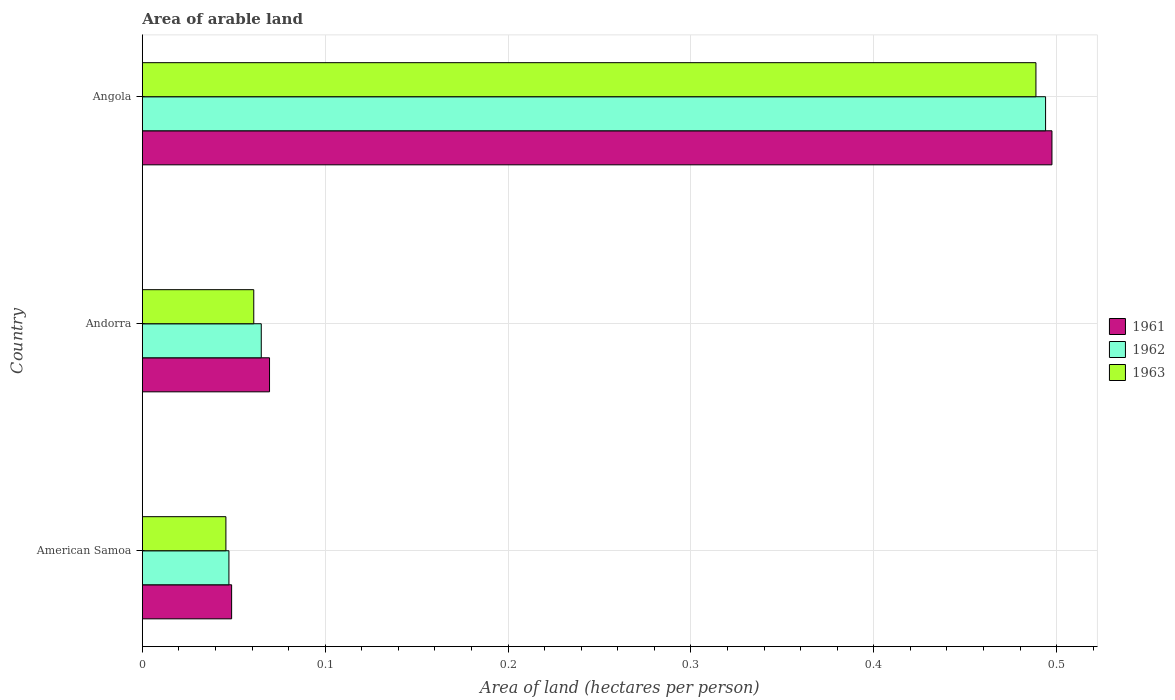Are the number of bars per tick equal to the number of legend labels?
Your answer should be compact. Yes. Are the number of bars on each tick of the Y-axis equal?
Your answer should be compact. Yes. How many bars are there on the 1st tick from the top?
Offer a terse response. 3. What is the label of the 1st group of bars from the top?
Make the answer very short. Angola. What is the total arable land in 1963 in Andorra?
Keep it short and to the point. 0.06. Across all countries, what is the maximum total arable land in 1962?
Make the answer very short. 0.49. Across all countries, what is the minimum total arable land in 1962?
Make the answer very short. 0.05. In which country was the total arable land in 1963 maximum?
Your answer should be compact. Angola. In which country was the total arable land in 1962 minimum?
Give a very brief answer. American Samoa. What is the total total arable land in 1962 in the graph?
Your answer should be compact. 0.61. What is the difference between the total arable land in 1963 in American Samoa and that in Angola?
Keep it short and to the point. -0.44. What is the difference between the total arable land in 1962 in Andorra and the total arable land in 1961 in Angola?
Provide a succinct answer. -0.43. What is the average total arable land in 1963 per country?
Your answer should be compact. 0.2. What is the difference between the total arable land in 1961 and total arable land in 1962 in Angola?
Ensure brevity in your answer.  0. What is the ratio of the total arable land in 1961 in American Samoa to that in Angola?
Offer a terse response. 0.1. Is the total arable land in 1963 in American Samoa less than that in Angola?
Provide a succinct answer. Yes. Is the difference between the total arable land in 1961 in American Samoa and Angola greater than the difference between the total arable land in 1962 in American Samoa and Angola?
Your response must be concise. No. What is the difference between the highest and the second highest total arable land in 1961?
Your response must be concise. 0.43. What is the difference between the highest and the lowest total arable land in 1962?
Your response must be concise. 0.45. In how many countries, is the total arable land in 1961 greater than the average total arable land in 1961 taken over all countries?
Make the answer very short. 1. What does the 3rd bar from the top in Angola represents?
Give a very brief answer. 1961. What does the 2nd bar from the bottom in American Samoa represents?
Make the answer very short. 1962. Are all the bars in the graph horizontal?
Give a very brief answer. Yes. How many countries are there in the graph?
Your answer should be very brief. 3. Are the values on the major ticks of X-axis written in scientific E-notation?
Make the answer very short. No. Does the graph contain any zero values?
Offer a terse response. No. Does the graph contain grids?
Your answer should be compact. Yes. Where does the legend appear in the graph?
Keep it short and to the point. Center right. How many legend labels are there?
Your response must be concise. 3. How are the legend labels stacked?
Offer a terse response. Vertical. What is the title of the graph?
Your response must be concise. Area of arable land. Does "1996" appear as one of the legend labels in the graph?
Keep it short and to the point. No. What is the label or title of the X-axis?
Your answer should be compact. Area of land (hectares per person). What is the Area of land (hectares per person) in 1961 in American Samoa?
Keep it short and to the point. 0.05. What is the Area of land (hectares per person) in 1962 in American Samoa?
Give a very brief answer. 0.05. What is the Area of land (hectares per person) in 1963 in American Samoa?
Provide a succinct answer. 0.05. What is the Area of land (hectares per person) in 1961 in Andorra?
Keep it short and to the point. 0.07. What is the Area of land (hectares per person) of 1962 in Andorra?
Give a very brief answer. 0.07. What is the Area of land (hectares per person) of 1963 in Andorra?
Give a very brief answer. 0.06. What is the Area of land (hectares per person) of 1961 in Angola?
Your answer should be very brief. 0.5. What is the Area of land (hectares per person) in 1962 in Angola?
Your answer should be compact. 0.49. What is the Area of land (hectares per person) in 1963 in Angola?
Ensure brevity in your answer.  0.49. Across all countries, what is the maximum Area of land (hectares per person) in 1961?
Give a very brief answer. 0.5. Across all countries, what is the maximum Area of land (hectares per person) of 1962?
Provide a short and direct response. 0.49. Across all countries, what is the maximum Area of land (hectares per person) of 1963?
Your answer should be compact. 0.49. Across all countries, what is the minimum Area of land (hectares per person) of 1961?
Offer a very short reply. 0.05. Across all countries, what is the minimum Area of land (hectares per person) of 1962?
Offer a very short reply. 0.05. Across all countries, what is the minimum Area of land (hectares per person) in 1963?
Give a very brief answer. 0.05. What is the total Area of land (hectares per person) of 1961 in the graph?
Give a very brief answer. 0.62. What is the total Area of land (hectares per person) in 1962 in the graph?
Offer a very short reply. 0.61. What is the total Area of land (hectares per person) in 1963 in the graph?
Offer a very short reply. 0.6. What is the difference between the Area of land (hectares per person) of 1961 in American Samoa and that in Andorra?
Make the answer very short. -0.02. What is the difference between the Area of land (hectares per person) of 1962 in American Samoa and that in Andorra?
Offer a terse response. -0.02. What is the difference between the Area of land (hectares per person) in 1963 in American Samoa and that in Andorra?
Provide a succinct answer. -0.02. What is the difference between the Area of land (hectares per person) of 1961 in American Samoa and that in Angola?
Your response must be concise. -0.45. What is the difference between the Area of land (hectares per person) in 1962 in American Samoa and that in Angola?
Keep it short and to the point. -0.45. What is the difference between the Area of land (hectares per person) in 1963 in American Samoa and that in Angola?
Offer a very short reply. -0.44. What is the difference between the Area of land (hectares per person) in 1961 in Andorra and that in Angola?
Provide a succinct answer. -0.43. What is the difference between the Area of land (hectares per person) of 1962 in Andorra and that in Angola?
Offer a terse response. -0.43. What is the difference between the Area of land (hectares per person) of 1963 in Andorra and that in Angola?
Offer a very short reply. -0.43. What is the difference between the Area of land (hectares per person) in 1961 in American Samoa and the Area of land (hectares per person) in 1962 in Andorra?
Offer a terse response. -0.02. What is the difference between the Area of land (hectares per person) in 1961 in American Samoa and the Area of land (hectares per person) in 1963 in Andorra?
Give a very brief answer. -0.01. What is the difference between the Area of land (hectares per person) of 1962 in American Samoa and the Area of land (hectares per person) of 1963 in Andorra?
Offer a terse response. -0.01. What is the difference between the Area of land (hectares per person) of 1961 in American Samoa and the Area of land (hectares per person) of 1962 in Angola?
Your answer should be compact. -0.45. What is the difference between the Area of land (hectares per person) of 1961 in American Samoa and the Area of land (hectares per person) of 1963 in Angola?
Your answer should be compact. -0.44. What is the difference between the Area of land (hectares per person) of 1962 in American Samoa and the Area of land (hectares per person) of 1963 in Angola?
Your answer should be compact. -0.44. What is the difference between the Area of land (hectares per person) in 1961 in Andorra and the Area of land (hectares per person) in 1962 in Angola?
Offer a very short reply. -0.42. What is the difference between the Area of land (hectares per person) in 1961 in Andorra and the Area of land (hectares per person) in 1963 in Angola?
Offer a terse response. -0.42. What is the difference between the Area of land (hectares per person) of 1962 in Andorra and the Area of land (hectares per person) of 1963 in Angola?
Your answer should be compact. -0.42. What is the average Area of land (hectares per person) in 1961 per country?
Make the answer very short. 0.21. What is the average Area of land (hectares per person) of 1962 per country?
Your answer should be very brief. 0.2. What is the average Area of land (hectares per person) of 1963 per country?
Make the answer very short. 0.2. What is the difference between the Area of land (hectares per person) in 1961 and Area of land (hectares per person) in 1962 in American Samoa?
Give a very brief answer. 0. What is the difference between the Area of land (hectares per person) in 1961 and Area of land (hectares per person) in 1963 in American Samoa?
Make the answer very short. 0. What is the difference between the Area of land (hectares per person) of 1962 and Area of land (hectares per person) of 1963 in American Samoa?
Offer a terse response. 0. What is the difference between the Area of land (hectares per person) of 1961 and Area of land (hectares per person) of 1962 in Andorra?
Keep it short and to the point. 0. What is the difference between the Area of land (hectares per person) in 1961 and Area of land (hectares per person) in 1963 in Andorra?
Give a very brief answer. 0.01. What is the difference between the Area of land (hectares per person) of 1962 and Area of land (hectares per person) of 1963 in Andorra?
Offer a very short reply. 0. What is the difference between the Area of land (hectares per person) of 1961 and Area of land (hectares per person) of 1962 in Angola?
Make the answer very short. 0. What is the difference between the Area of land (hectares per person) of 1961 and Area of land (hectares per person) of 1963 in Angola?
Offer a terse response. 0.01. What is the difference between the Area of land (hectares per person) of 1962 and Area of land (hectares per person) of 1963 in Angola?
Offer a very short reply. 0.01. What is the ratio of the Area of land (hectares per person) of 1961 in American Samoa to that in Andorra?
Make the answer very short. 0.7. What is the ratio of the Area of land (hectares per person) in 1962 in American Samoa to that in Andorra?
Ensure brevity in your answer.  0.73. What is the ratio of the Area of land (hectares per person) in 1963 in American Samoa to that in Andorra?
Your response must be concise. 0.75. What is the ratio of the Area of land (hectares per person) in 1961 in American Samoa to that in Angola?
Provide a succinct answer. 0.1. What is the ratio of the Area of land (hectares per person) of 1962 in American Samoa to that in Angola?
Your response must be concise. 0.1. What is the ratio of the Area of land (hectares per person) of 1963 in American Samoa to that in Angola?
Your answer should be compact. 0.09. What is the ratio of the Area of land (hectares per person) of 1961 in Andorra to that in Angola?
Provide a succinct answer. 0.14. What is the ratio of the Area of land (hectares per person) of 1962 in Andorra to that in Angola?
Provide a short and direct response. 0.13. What is the ratio of the Area of land (hectares per person) in 1963 in Andorra to that in Angola?
Provide a short and direct response. 0.12. What is the difference between the highest and the second highest Area of land (hectares per person) of 1961?
Your response must be concise. 0.43. What is the difference between the highest and the second highest Area of land (hectares per person) of 1962?
Ensure brevity in your answer.  0.43. What is the difference between the highest and the second highest Area of land (hectares per person) in 1963?
Your response must be concise. 0.43. What is the difference between the highest and the lowest Area of land (hectares per person) of 1961?
Ensure brevity in your answer.  0.45. What is the difference between the highest and the lowest Area of land (hectares per person) of 1962?
Offer a terse response. 0.45. What is the difference between the highest and the lowest Area of land (hectares per person) of 1963?
Provide a succinct answer. 0.44. 